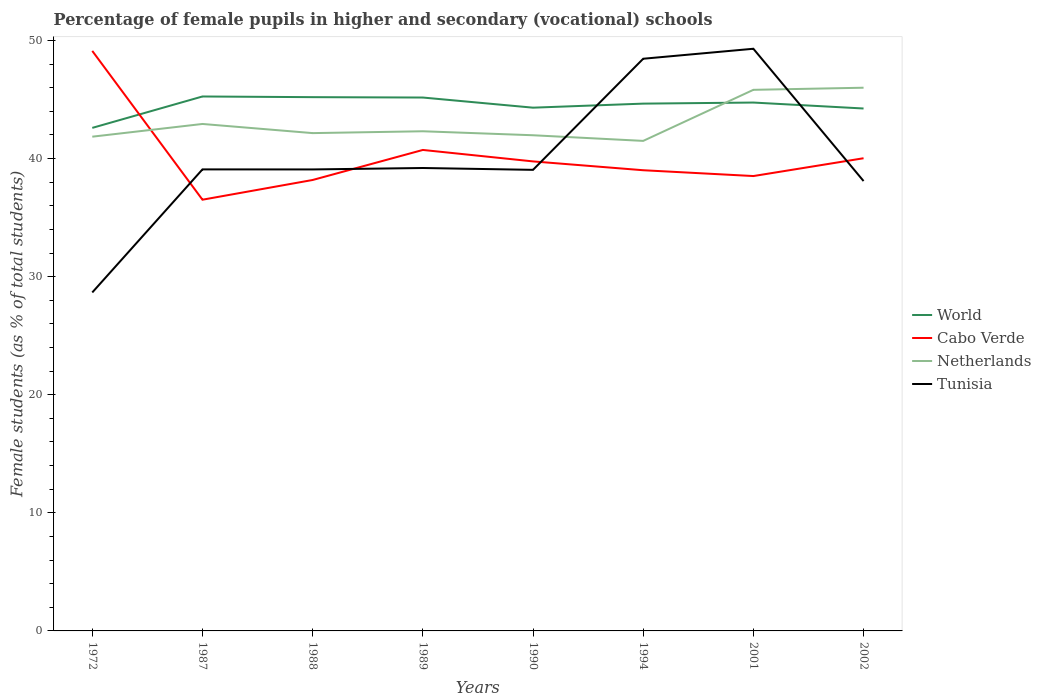Is the number of lines equal to the number of legend labels?
Ensure brevity in your answer.  Yes. Across all years, what is the maximum percentage of female pupils in higher and secondary schools in World?
Provide a succinct answer. 42.6. What is the total percentage of female pupils in higher and secondary schools in Tunisia in the graph?
Give a very brief answer. -19.79. What is the difference between the highest and the second highest percentage of female pupils in higher and secondary schools in Cabo Verde?
Ensure brevity in your answer.  12.6. Is the percentage of female pupils in higher and secondary schools in Cabo Verde strictly greater than the percentage of female pupils in higher and secondary schools in Tunisia over the years?
Offer a very short reply. No. How many lines are there?
Give a very brief answer. 4. How many years are there in the graph?
Your response must be concise. 8. How are the legend labels stacked?
Offer a terse response. Vertical. What is the title of the graph?
Ensure brevity in your answer.  Percentage of female pupils in higher and secondary (vocational) schools. Does "St. Martin (French part)" appear as one of the legend labels in the graph?
Ensure brevity in your answer.  No. What is the label or title of the X-axis?
Ensure brevity in your answer.  Years. What is the label or title of the Y-axis?
Give a very brief answer. Female students (as % of total students). What is the Female students (as % of total students) in World in 1972?
Provide a succinct answer. 42.6. What is the Female students (as % of total students) in Cabo Verde in 1972?
Your answer should be very brief. 49.12. What is the Female students (as % of total students) in Netherlands in 1972?
Offer a terse response. 41.85. What is the Female students (as % of total students) in Tunisia in 1972?
Offer a terse response. 28.66. What is the Female students (as % of total students) of World in 1987?
Your answer should be compact. 45.26. What is the Female students (as % of total students) of Cabo Verde in 1987?
Make the answer very short. 36.52. What is the Female students (as % of total students) in Netherlands in 1987?
Provide a short and direct response. 42.93. What is the Female students (as % of total students) of Tunisia in 1987?
Keep it short and to the point. 39.08. What is the Female students (as % of total students) in World in 1988?
Offer a very short reply. 45.2. What is the Female students (as % of total students) of Cabo Verde in 1988?
Offer a terse response. 38.19. What is the Female students (as % of total students) of Netherlands in 1988?
Provide a short and direct response. 42.16. What is the Female students (as % of total students) of Tunisia in 1988?
Ensure brevity in your answer.  39.08. What is the Female students (as % of total students) in World in 1989?
Your answer should be compact. 45.17. What is the Female students (as % of total students) in Cabo Verde in 1989?
Your answer should be compact. 40.73. What is the Female students (as % of total students) of Netherlands in 1989?
Ensure brevity in your answer.  42.31. What is the Female students (as % of total students) in Tunisia in 1989?
Your answer should be compact. 39.2. What is the Female students (as % of total students) in World in 1990?
Keep it short and to the point. 44.31. What is the Female students (as % of total students) of Cabo Verde in 1990?
Your answer should be very brief. 39.76. What is the Female students (as % of total students) in Netherlands in 1990?
Your answer should be compact. 41.98. What is the Female students (as % of total students) in Tunisia in 1990?
Make the answer very short. 39.05. What is the Female students (as % of total students) in World in 1994?
Ensure brevity in your answer.  44.65. What is the Female students (as % of total students) of Cabo Verde in 1994?
Your answer should be very brief. 39.01. What is the Female students (as % of total students) of Netherlands in 1994?
Your answer should be very brief. 41.5. What is the Female students (as % of total students) of Tunisia in 1994?
Keep it short and to the point. 48.45. What is the Female students (as % of total students) in World in 2001?
Offer a terse response. 44.74. What is the Female students (as % of total students) in Cabo Verde in 2001?
Ensure brevity in your answer.  38.52. What is the Female students (as % of total students) in Netherlands in 2001?
Give a very brief answer. 45.82. What is the Female students (as % of total students) in Tunisia in 2001?
Your answer should be compact. 49.3. What is the Female students (as % of total students) in World in 2002?
Offer a terse response. 44.24. What is the Female students (as % of total students) of Cabo Verde in 2002?
Keep it short and to the point. 40.03. What is the Female students (as % of total students) in Netherlands in 2002?
Your answer should be very brief. 46. What is the Female students (as % of total students) in Tunisia in 2002?
Make the answer very short. 38.1. Across all years, what is the maximum Female students (as % of total students) of World?
Your response must be concise. 45.26. Across all years, what is the maximum Female students (as % of total students) of Cabo Verde?
Make the answer very short. 49.12. Across all years, what is the maximum Female students (as % of total students) in Netherlands?
Make the answer very short. 46. Across all years, what is the maximum Female students (as % of total students) in Tunisia?
Provide a short and direct response. 49.3. Across all years, what is the minimum Female students (as % of total students) of World?
Give a very brief answer. 42.6. Across all years, what is the minimum Female students (as % of total students) in Cabo Verde?
Offer a terse response. 36.52. Across all years, what is the minimum Female students (as % of total students) in Netherlands?
Ensure brevity in your answer.  41.5. Across all years, what is the minimum Female students (as % of total students) in Tunisia?
Your answer should be very brief. 28.66. What is the total Female students (as % of total students) of World in the graph?
Provide a short and direct response. 356.18. What is the total Female students (as % of total students) in Cabo Verde in the graph?
Give a very brief answer. 321.87. What is the total Female students (as % of total students) in Netherlands in the graph?
Ensure brevity in your answer.  344.55. What is the total Female students (as % of total students) in Tunisia in the graph?
Ensure brevity in your answer.  320.92. What is the difference between the Female students (as % of total students) in World in 1972 and that in 1987?
Make the answer very short. -2.66. What is the difference between the Female students (as % of total students) of Cabo Verde in 1972 and that in 1987?
Give a very brief answer. 12.6. What is the difference between the Female students (as % of total students) of Netherlands in 1972 and that in 1987?
Offer a terse response. -1.08. What is the difference between the Female students (as % of total students) in Tunisia in 1972 and that in 1987?
Offer a very short reply. -10.42. What is the difference between the Female students (as % of total students) in World in 1972 and that in 1988?
Provide a succinct answer. -2.6. What is the difference between the Female students (as % of total students) of Cabo Verde in 1972 and that in 1988?
Provide a succinct answer. 10.93. What is the difference between the Female students (as % of total students) of Netherlands in 1972 and that in 1988?
Provide a succinct answer. -0.3. What is the difference between the Female students (as % of total students) of Tunisia in 1972 and that in 1988?
Ensure brevity in your answer.  -10.42. What is the difference between the Female students (as % of total students) in World in 1972 and that in 1989?
Provide a short and direct response. -2.57. What is the difference between the Female students (as % of total students) in Cabo Verde in 1972 and that in 1989?
Make the answer very short. 8.39. What is the difference between the Female students (as % of total students) of Netherlands in 1972 and that in 1989?
Provide a succinct answer. -0.46. What is the difference between the Female students (as % of total students) of Tunisia in 1972 and that in 1989?
Offer a very short reply. -10.54. What is the difference between the Female students (as % of total students) of World in 1972 and that in 1990?
Your answer should be very brief. -1.71. What is the difference between the Female students (as % of total students) of Cabo Verde in 1972 and that in 1990?
Ensure brevity in your answer.  9.36. What is the difference between the Female students (as % of total students) in Netherlands in 1972 and that in 1990?
Keep it short and to the point. -0.12. What is the difference between the Female students (as % of total students) in Tunisia in 1972 and that in 1990?
Keep it short and to the point. -10.38. What is the difference between the Female students (as % of total students) in World in 1972 and that in 1994?
Provide a short and direct response. -2.05. What is the difference between the Female students (as % of total students) in Cabo Verde in 1972 and that in 1994?
Provide a succinct answer. 10.1. What is the difference between the Female students (as % of total students) in Netherlands in 1972 and that in 1994?
Give a very brief answer. 0.36. What is the difference between the Female students (as % of total students) in Tunisia in 1972 and that in 1994?
Your answer should be very brief. -19.79. What is the difference between the Female students (as % of total students) of World in 1972 and that in 2001?
Ensure brevity in your answer.  -2.15. What is the difference between the Female students (as % of total students) of Cabo Verde in 1972 and that in 2001?
Your answer should be very brief. 10.6. What is the difference between the Female students (as % of total students) in Netherlands in 1972 and that in 2001?
Provide a short and direct response. -3.97. What is the difference between the Female students (as % of total students) in Tunisia in 1972 and that in 2001?
Offer a very short reply. -20.64. What is the difference between the Female students (as % of total students) of World in 1972 and that in 2002?
Provide a short and direct response. -1.64. What is the difference between the Female students (as % of total students) of Cabo Verde in 1972 and that in 2002?
Offer a terse response. 9.09. What is the difference between the Female students (as % of total students) in Netherlands in 1972 and that in 2002?
Your answer should be compact. -4.15. What is the difference between the Female students (as % of total students) of Tunisia in 1972 and that in 2002?
Your answer should be compact. -9.43. What is the difference between the Female students (as % of total students) in World in 1987 and that in 1988?
Ensure brevity in your answer.  0.06. What is the difference between the Female students (as % of total students) in Cabo Verde in 1987 and that in 1988?
Provide a short and direct response. -1.67. What is the difference between the Female students (as % of total students) in Netherlands in 1987 and that in 1988?
Your answer should be very brief. 0.77. What is the difference between the Female students (as % of total students) of Tunisia in 1987 and that in 1988?
Offer a very short reply. 0.01. What is the difference between the Female students (as % of total students) in World in 1987 and that in 1989?
Provide a succinct answer. 0.09. What is the difference between the Female students (as % of total students) in Cabo Verde in 1987 and that in 1989?
Make the answer very short. -4.21. What is the difference between the Female students (as % of total students) of Netherlands in 1987 and that in 1989?
Give a very brief answer. 0.62. What is the difference between the Female students (as % of total students) of Tunisia in 1987 and that in 1989?
Offer a very short reply. -0.12. What is the difference between the Female students (as % of total students) in World in 1987 and that in 1990?
Give a very brief answer. 0.95. What is the difference between the Female students (as % of total students) of Cabo Verde in 1987 and that in 1990?
Offer a terse response. -3.24. What is the difference between the Female students (as % of total students) of Netherlands in 1987 and that in 1990?
Give a very brief answer. 0.96. What is the difference between the Female students (as % of total students) of Tunisia in 1987 and that in 1990?
Your answer should be very brief. 0.04. What is the difference between the Female students (as % of total students) in World in 1987 and that in 1994?
Your answer should be compact. 0.61. What is the difference between the Female students (as % of total students) in Cabo Verde in 1987 and that in 1994?
Ensure brevity in your answer.  -2.5. What is the difference between the Female students (as % of total students) in Netherlands in 1987 and that in 1994?
Provide a succinct answer. 1.43. What is the difference between the Female students (as % of total students) in Tunisia in 1987 and that in 1994?
Your answer should be compact. -9.37. What is the difference between the Female students (as % of total students) in World in 1987 and that in 2001?
Offer a terse response. 0.51. What is the difference between the Female students (as % of total students) in Cabo Verde in 1987 and that in 2001?
Ensure brevity in your answer.  -2. What is the difference between the Female students (as % of total students) of Netherlands in 1987 and that in 2001?
Your answer should be compact. -2.89. What is the difference between the Female students (as % of total students) of Tunisia in 1987 and that in 2001?
Provide a succinct answer. -10.21. What is the difference between the Female students (as % of total students) in Cabo Verde in 1987 and that in 2002?
Keep it short and to the point. -3.51. What is the difference between the Female students (as % of total students) in Netherlands in 1987 and that in 2002?
Keep it short and to the point. -3.07. What is the difference between the Female students (as % of total students) in Tunisia in 1987 and that in 2002?
Make the answer very short. 0.99. What is the difference between the Female students (as % of total students) in World in 1988 and that in 1989?
Provide a short and direct response. 0.03. What is the difference between the Female students (as % of total students) in Cabo Verde in 1988 and that in 1989?
Make the answer very short. -2.54. What is the difference between the Female students (as % of total students) of Netherlands in 1988 and that in 1989?
Offer a terse response. -0.16. What is the difference between the Female students (as % of total students) in Tunisia in 1988 and that in 1989?
Make the answer very short. -0.12. What is the difference between the Female students (as % of total students) in World in 1988 and that in 1990?
Make the answer very short. 0.89. What is the difference between the Female students (as % of total students) in Cabo Verde in 1988 and that in 1990?
Offer a very short reply. -1.57. What is the difference between the Female students (as % of total students) in Netherlands in 1988 and that in 1990?
Offer a very short reply. 0.18. What is the difference between the Female students (as % of total students) of Tunisia in 1988 and that in 1990?
Make the answer very short. 0.03. What is the difference between the Female students (as % of total students) in World in 1988 and that in 1994?
Offer a terse response. 0.55. What is the difference between the Female students (as % of total students) in Cabo Verde in 1988 and that in 1994?
Offer a very short reply. -0.83. What is the difference between the Female students (as % of total students) in Netherlands in 1988 and that in 1994?
Offer a terse response. 0.66. What is the difference between the Female students (as % of total students) in Tunisia in 1988 and that in 1994?
Provide a short and direct response. -9.37. What is the difference between the Female students (as % of total students) in World in 1988 and that in 2001?
Provide a succinct answer. 0.46. What is the difference between the Female students (as % of total students) of Cabo Verde in 1988 and that in 2001?
Your answer should be very brief. -0.33. What is the difference between the Female students (as % of total students) in Netherlands in 1988 and that in 2001?
Offer a terse response. -3.66. What is the difference between the Female students (as % of total students) of Tunisia in 1988 and that in 2001?
Give a very brief answer. -10.22. What is the difference between the Female students (as % of total students) in World in 1988 and that in 2002?
Keep it short and to the point. 0.96. What is the difference between the Female students (as % of total students) of Cabo Verde in 1988 and that in 2002?
Offer a terse response. -1.84. What is the difference between the Female students (as % of total students) in Netherlands in 1988 and that in 2002?
Offer a terse response. -3.84. What is the difference between the Female students (as % of total students) in Tunisia in 1988 and that in 2002?
Offer a very short reply. 0.98. What is the difference between the Female students (as % of total students) of World in 1989 and that in 1990?
Your response must be concise. 0.86. What is the difference between the Female students (as % of total students) in Cabo Verde in 1989 and that in 1990?
Offer a terse response. 0.97. What is the difference between the Female students (as % of total students) in Netherlands in 1989 and that in 1990?
Provide a succinct answer. 0.34. What is the difference between the Female students (as % of total students) of Tunisia in 1989 and that in 1990?
Offer a terse response. 0.16. What is the difference between the Female students (as % of total students) of World in 1989 and that in 1994?
Ensure brevity in your answer.  0.52. What is the difference between the Female students (as % of total students) in Cabo Verde in 1989 and that in 1994?
Your answer should be compact. 1.72. What is the difference between the Female students (as % of total students) of Netherlands in 1989 and that in 1994?
Provide a short and direct response. 0.81. What is the difference between the Female students (as % of total students) in Tunisia in 1989 and that in 1994?
Offer a terse response. -9.25. What is the difference between the Female students (as % of total students) in World in 1989 and that in 2001?
Offer a very short reply. 0.42. What is the difference between the Female students (as % of total students) in Cabo Verde in 1989 and that in 2001?
Provide a short and direct response. 2.21. What is the difference between the Female students (as % of total students) in Netherlands in 1989 and that in 2001?
Give a very brief answer. -3.51. What is the difference between the Female students (as % of total students) of Tunisia in 1989 and that in 2001?
Your answer should be compact. -10.1. What is the difference between the Female students (as % of total students) in World in 1989 and that in 2002?
Provide a succinct answer. 0.93. What is the difference between the Female students (as % of total students) in Cabo Verde in 1989 and that in 2002?
Offer a terse response. 0.7. What is the difference between the Female students (as % of total students) of Netherlands in 1989 and that in 2002?
Give a very brief answer. -3.69. What is the difference between the Female students (as % of total students) of Tunisia in 1989 and that in 2002?
Provide a short and direct response. 1.1. What is the difference between the Female students (as % of total students) of World in 1990 and that in 1994?
Your response must be concise. -0.34. What is the difference between the Female students (as % of total students) in Cabo Verde in 1990 and that in 1994?
Make the answer very short. 0.75. What is the difference between the Female students (as % of total students) of Netherlands in 1990 and that in 1994?
Make the answer very short. 0.48. What is the difference between the Female students (as % of total students) of Tunisia in 1990 and that in 1994?
Ensure brevity in your answer.  -9.41. What is the difference between the Female students (as % of total students) in World in 1990 and that in 2001?
Keep it short and to the point. -0.43. What is the difference between the Female students (as % of total students) in Cabo Verde in 1990 and that in 2001?
Give a very brief answer. 1.24. What is the difference between the Female students (as % of total students) of Netherlands in 1990 and that in 2001?
Provide a succinct answer. -3.85. What is the difference between the Female students (as % of total students) of Tunisia in 1990 and that in 2001?
Provide a succinct answer. -10.25. What is the difference between the Female students (as % of total students) of World in 1990 and that in 2002?
Your response must be concise. 0.07. What is the difference between the Female students (as % of total students) of Cabo Verde in 1990 and that in 2002?
Keep it short and to the point. -0.27. What is the difference between the Female students (as % of total students) of Netherlands in 1990 and that in 2002?
Your response must be concise. -4.02. What is the difference between the Female students (as % of total students) of Tunisia in 1990 and that in 2002?
Offer a terse response. 0.95. What is the difference between the Female students (as % of total students) of World in 1994 and that in 2001?
Keep it short and to the point. -0.09. What is the difference between the Female students (as % of total students) of Cabo Verde in 1994 and that in 2001?
Your response must be concise. 0.49. What is the difference between the Female students (as % of total students) in Netherlands in 1994 and that in 2001?
Offer a very short reply. -4.32. What is the difference between the Female students (as % of total students) of Tunisia in 1994 and that in 2001?
Offer a very short reply. -0.85. What is the difference between the Female students (as % of total students) in World in 1994 and that in 2002?
Offer a very short reply. 0.41. What is the difference between the Female students (as % of total students) in Cabo Verde in 1994 and that in 2002?
Make the answer very short. -1.02. What is the difference between the Female students (as % of total students) of Netherlands in 1994 and that in 2002?
Keep it short and to the point. -4.5. What is the difference between the Female students (as % of total students) in Tunisia in 1994 and that in 2002?
Offer a terse response. 10.36. What is the difference between the Female students (as % of total students) in World in 2001 and that in 2002?
Keep it short and to the point. 0.5. What is the difference between the Female students (as % of total students) of Cabo Verde in 2001 and that in 2002?
Offer a very short reply. -1.51. What is the difference between the Female students (as % of total students) of Netherlands in 2001 and that in 2002?
Your answer should be compact. -0.18. What is the difference between the Female students (as % of total students) in Tunisia in 2001 and that in 2002?
Your answer should be compact. 11.2. What is the difference between the Female students (as % of total students) of World in 1972 and the Female students (as % of total students) of Cabo Verde in 1987?
Keep it short and to the point. 6.08. What is the difference between the Female students (as % of total students) in World in 1972 and the Female students (as % of total students) in Netherlands in 1987?
Keep it short and to the point. -0.33. What is the difference between the Female students (as % of total students) of World in 1972 and the Female students (as % of total students) of Tunisia in 1987?
Give a very brief answer. 3.51. What is the difference between the Female students (as % of total students) of Cabo Verde in 1972 and the Female students (as % of total students) of Netherlands in 1987?
Provide a short and direct response. 6.19. What is the difference between the Female students (as % of total students) of Cabo Verde in 1972 and the Female students (as % of total students) of Tunisia in 1987?
Offer a terse response. 10.03. What is the difference between the Female students (as % of total students) in Netherlands in 1972 and the Female students (as % of total students) in Tunisia in 1987?
Ensure brevity in your answer.  2.77. What is the difference between the Female students (as % of total students) in World in 1972 and the Female students (as % of total students) in Cabo Verde in 1988?
Offer a terse response. 4.41. What is the difference between the Female students (as % of total students) in World in 1972 and the Female students (as % of total students) in Netherlands in 1988?
Keep it short and to the point. 0.44. What is the difference between the Female students (as % of total students) of World in 1972 and the Female students (as % of total students) of Tunisia in 1988?
Offer a terse response. 3.52. What is the difference between the Female students (as % of total students) in Cabo Verde in 1972 and the Female students (as % of total students) in Netherlands in 1988?
Offer a terse response. 6.96. What is the difference between the Female students (as % of total students) of Cabo Verde in 1972 and the Female students (as % of total students) of Tunisia in 1988?
Keep it short and to the point. 10.04. What is the difference between the Female students (as % of total students) of Netherlands in 1972 and the Female students (as % of total students) of Tunisia in 1988?
Offer a terse response. 2.78. What is the difference between the Female students (as % of total students) of World in 1972 and the Female students (as % of total students) of Cabo Verde in 1989?
Offer a terse response. 1.87. What is the difference between the Female students (as % of total students) of World in 1972 and the Female students (as % of total students) of Netherlands in 1989?
Ensure brevity in your answer.  0.29. What is the difference between the Female students (as % of total students) of World in 1972 and the Female students (as % of total students) of Tunisia in 1989?
Offer a very short reply. 3.4. What is the difference between the Female students (as % of total students) in Cabo Verde in 1972 and the Female students (as % of total students) in Netherlands in 1989?
Ensure brevity in your answer.  6.8. What is the difference between the Female students (as % of total students) of Cabo Verde in 1972 and the Female students (as % of total students) of Tunisia in 1989?
Provide a short and direct response. 9.92. What is the difference between the Female students (as % of total students) in Netherlands in 1972 and the Female students (as % of total students) in Tunisia in 1989?
Offer a terse response. 2.65. What is the difference between the Female students (as % of total students) of World in 1972 and the Female students (as % of total students) of Cabo Verde in 1990?
Provide a succinct answer. 2.84. What is the difference between the Female students (as % of total students) of World in 1972 and the Female students (as % of total students) of Netherlands in 1990?
Keep it short and to the point. 0.62. What is the difference between the Female students (as % of total students) in World in 1972 and the Female students (as % of total students) in Tunisia in 1990?
Make the answer very short. 3.55. What is the difference between the Female students (as % of total students) in Cabo Verde in 1972 and the Female students (as % of total students) in Netherlands in 1990?
Keep it short and to the point. 7.14. What is the difference between the Female students (as % of total students) in Cabo Verde in 1972 and the Female students (as % of total students) in Tunisia in 1990?
Ensure brevity in your answer.  10.07. What is the difference between the Female students (as % of total students) in Netherlands in 1972 and the Female students (as % of total students) in Tunisia in 1990?
Offer a terse response. 2.81. What is the difference between the Female students (as % of total students) in World in 1972 and the Female students (as % of total students) in Cabo Verde in 1994?
Give a very brief answer. 3.59. What is the difference between the Female students (as % of total students) in World in 1972 and the Female students (as % of total students) in Netherlands in 1994?
Make the answer very short. 1.1. What is the difference between the Female students (as % of total students) in World in 1972 and the Female students (as % of total students) in Tunisia in 1994?
Ensure brevity in your answer.  -5.86. What is the difference between the Female students (as % of total students) of Cabo Verde in 1972 and the Female students (as % of total students) of Netherlands in 1994?
Provide a short and direct response. 7.62. What is the difference between the Female students (as % of total students) of Cabo Verde in 1972 and the Female students (as % of total students) of Tunisia in 1994?
Give a very brief answer. 0.66. What is the difference between the Female students (as % of total students) in Netherlands in 1972 and the Female students (as % of total students) in Tunisia in 1994?
Keep it short and to the point. -6.6. What is the difference between the Female students (as % of total students) in World in 1972 and the Female students (as % of total students) in Cabo Verde in 2001?
Offer a terse response. 4.08. What is the difference between the Female students (as % of total students) of World in 1972 and the Female students (as % of total students) of Netherlands in 2001?
Your response must be concise. -3.22. What is the difference between the Female students (as % of total students) in World in 1972 and the Female students (as % of total students) in Tunisia in 2001?
Give a very brief answer. -6.7. What is the difference between the Female students (as % of total students) in Cabo Verde in 1972 and the Female students (as % of total students) in Netherlands in 2001?
Provide a succinct answer. 3.3. What is the difference between the Female students (as % of total students) in Cabo Verde in 1972 and the Female students (as % of total students) in Tunisia in 2001?
Provide a succinct answer. -0.18. What is the difference between the Female students (as % of total students) in Netherlands in 1972 and the Female students (as % of total students) in Tunisia in 2001?
Keep it short and to the point. -7.44. What is the difference between the Female students (as % of total students) in World in 1972 and the Female students (as % of total students) in Cabo Verde in 2002?
Your response must be concise. 2.57. What is the difference between the Female students (as % of total students) of World in 1972 and the Female students (as % of total students) of Netherlands in 2002?
Keep it short and to the point. -3.4. What is the difference between the Female students (as % of total students) of World in 1972 and the Female students (as % of total students) of Tunisia in 2002?
Give a very brief answer. 4.5. What is the difference between the Female students (as % of total students) of Cabo Verde in 1972 and the Female students (as % of total students) of Netherlands in 2002?
Offer a terse response. 3.12. What is the difference between the Female students (as % of total students) of Cabo Verde in 1972 and the Female students (as % of total students) of Tunisia in 2002?
Your answer should be very brief. 11.02. What is the difference between the Female students (as % of total students) in Netherlands in 1972 and the Female students (as % of total students) in Tunisia in 2002?
Provide a succinct answer. 3.76. What is the difference between the Female students (as % of total students) of World in 1987 and the Female students (as % of total students) of Cabo Verde in 1988?
Ensure brevity in your answer.  7.07. What is the difference between the Female students (as % of total students) of World in 1987 and the Female students (as % of total students) of Netherlands in 1988?
Your answer should be very brief. 3.1. What is the difference between the Female students (as % of total students) in World in 1987 and the Female students (as % of total students) in Tunisia in 1988?
Provide a short and direct response. 6.18. What is the difference between the Female students (as % of total students) of Cabo Verde in 1987 and the Female students (as % of total students) of Netherlands in 1988?
Your answer should be very brief. -5.64. What is the difference between the Female students (as % of total students) of Cabo Verde in 1987 and the Female students (as % of total students) of Tunisia in 1988?
Ensure brevity in your answer.  -2.56. What is the difference between the Female students (as % of total students) in Netherlands in 1987 and the Female students (as % of total students) in Tunisia in 1988?
Give a very brief answer. 3.85. What is the difference between the Female students (as % of total students) in World in 1987 and the Female students (as % of total students) in Cabo Verde in 1989?
Provide a succinct answer. 4.53. What is the difference between the Female students (as % of total students) of World in 1987 and the Female students (as % of total students) of Netherlands in 1989?
Make the answer very short. 2.95. What is the difference between the Female students (as % of total students) of World in 1987 and the Female students (as % of total students) of Tunisia in 1989?
Offer a terse response. 6.06. What is the difference between the Female students (as % of total students) of Cabo Verde in 1987 and the Female students (as % of total students) of Netherlands in 1989?
Your answer should be very brief. -5.79. What is the difference between the Female students (as % of total students) of Cabo Verde in 1987 and the Female students (as % of total students) of Tunisia in 1989?
Keep it short and to the point. -2.68. What is the difference between the Female students (as % of total students) in Netherlands in 1987 and the Female students (as % of total students) in Tunisia in 1989?
Your response must be concise. 3.73. What is the difference between the Female students (as % of total students) in World in 1987 and the Female students (as % of total students) in Cabo Verde in 1990?
Provide a succinct answer. 5.5. What is the difference between the Female students (as % of total students) in World in 1987 and the Female students (as % of total students) in Netherlands in 1990?
Offer a terse response. 3.28. What is the difference between the Female students (as % of total students) in World in 1987 and the Female students (as % of total students) in Tunisia in 1990?
Provide a succinct answer. 6.21. What is the difference between the Female students (as % of total students) in Cabo Verde in 1987 and the Female students (as % of total students) in Netherlands in 1990?
Make the answer very short. -5.46. What is the difference between the Female students (as % of total students) in Cabo Verde in 1987 and the Female students (as % of total students) in Tunisia in 1990?
Offer a terse response. -2.53. What is the difference between the Female students (as % of total students) of Netherlands in 1987 and the Female students (as % of total students) of Tunisia in 1990?
Provide a short and direct response. 3.89. What is the difference between the Female students (as % of total students) of World in 1987 and the Female students (as % of total students) of Cabo Verde in 1994?
Your response must be concise. 6.25. What is the difference between the Female students (as % of total students) in World in 1987 and the Female students (as % of total students) in Netherlands in 1994?
Offer a terse response. 3.76. What is the difference between the Female students (as % of total students) in World in 1987 and the Female students (as % of total students) in Tunisia in 1994?
Keep it short and to the point. -3.2. What is the difference between the Female students (as % of total students) of Cabo Verde in 1987 and the Female students (as % of total students) of Netherlands in 1994?
Ensure brevity in your answer.  -4.98. What is the difference between the Female students (as % of total students) of Cabo Verde in 1987 and the Female students (as % of total students) of Tunisia in 1994?
Provide a short and direct response. -11.94. What is the difference between the Female students (as % of total students) in Netherlands in 1987 and the Female students (as % of total students) in Tunisia in 1994?
Your answer should be compact. -5.52. What is the difference between the Female students (as % of total students) in World in 1987 and the Female students (as % of total students) in Cabo Verde in 2001?
Your response must be concise. 6.74. What is the difference between the Female students (as % of total students) in World in 1987 and the Female students (as % of total students) in Netherlands in 2001?
Your answer should be very brief. -0.56. What is the difference between the Female students (as % of total students) of World in 1987 and the Female students (as % of total students) of Tunisia in 2001?
Make the answer very short. -4.04. What is the difference between the Female students (as % of total students) in Cabo Verde in 1987 and the Female students (as % of total students) in Netherlands in 2001?
Keep it short and to the point. -9.3. What is the difference between the Female students (as % of total students) of Cabo Verde in 1987 and the Female students (as % of total students) of Tunisia in 2001?
Keep it short and to the point. -12.78. What is the difference between the Female students (as % of total students) in Netherlands in 1987 and the Female students (as % of total students) in Tunisia in 2001?
Offer a terse response. -6.37. What is the difference between the Female students (as % of total students) in World in 1987 and the Female students (as % of total students) in Cabo Verde in 2002?
Provide a succinct answer. 5.23. What is the difference between the Female students (as % of total students) in World in 1987 and the Female students (as % of total students) in Netherlands in 2002?
Make the answer very short. -0.74. What is the difference between the Female students (as % of total students) in World in 1987 and the Female students (as % of total students) in Tunisia in 2002?
Make the answer very short. 7.16. What is the difference between the Female students (as % of total students) of Cabo Verde in 1987 and the Female students (as % of total students) of Netherlands in 2002?
Offer a terse response. -9.48. What is the difference between the Female students (as % of total students) in Cabo Verde in 1987 and the Female students (as % of total students) in Tunisia in 2002?
Make the answer very short. -1.58. What is the difference between the Female students (as % of total students) of Netherlands in 1987 and the Female students (as % of total students) of Tunisia in 2002?
Ensure brevity in your answer.  4.83. What is the difference between the Female students (as % of total students) of World in 1988 and the Female students (as % of total students) of Cabo Verde in 1989?
Offer a terse response. 4.47. What is the difference between the Female students (as % of total students) in World in 1988 and the Female students (as % of total students) in Netherlands in 1989?
Your answer should be very brief. 2.89. What is the difference between the Female students (as % of total students) of World in 1988 and the Female students (as % of total students) of Tunisia in 1989?
Your answer should be compact. 6. What is the difference between the Female students (as % of total students) in Cabo Verde in 1988 and the Female students (as % of total students) in Netherlands in 1989?
Give a very brief answer. -4.13. What is the difference between the Female students (as % of total students) in Cabo Verde in 1988 and the Female students (as % of total students) in Tunisia in 1989?
Your answer should be very brief. -1.01. What is the difference between the Female students (as % of total students) of Netherlands in 1988 and the Female students (as % of total students) of Tunisia in 1989?
Provide a succinct answer. 2.96. What is the difference between the Female students (as % of total students) of World in 1988 and the Female students (as % of total students) of Cabo Verde in 1990?
Provide a succinct answer. 5.44. What is the difference between the Female students (as % of total students) of World in 1988 and the Female students (as % of total students) of Netherlands in 1990?
Provide a short and direct response. 3.23. What is the difference between the Female students (as % of total students) in World in 1988 and the Female students (as % of total students) in Tunisia in 1990?
Your answer should be very brief. 6.16. What is the difference between the Female students (as % of total students) of Cabo Verde in 1988 and the Female students (as % of total students) of Netherlands in 1990?
Offer a terse response. -3.79. What is the difference between the Female students (as % of total students) of Cabo Verde in 1988 and the Female students (as % of total students) of Tunisia in 1990?
Offer a very short reply. -0.86. What is the difference between the Female students (as % of total students) in Netherlands in 1988 and the Female students (as % of total students) in Tunisia in 1990?
Your answer should be compact. 3.11. What is the difference between the Female students (as % of total students) of World in 1988 and the Female students (as % of total students) of Cabo Verde in 1994?
Offer a terse response. 6.19. What is the difference between the Female students (as % of total students) of World in 1988 and the Female students (as % of total students) of Netherlands in 1994?
Your response must be concise. 3.7. What is the difference between the Female students (as % of total students) in World in 1988 and the Female students (as % of total students) in Tunisia in 1994?
Ensure brevity in your answer.  -3.25. What is the difference between the Female students (as % of total students) in Cabo Verde in 1988 and the Female students (as % of total students) in Netherlands in 1994?
Ensure brevity in your answer.  -3.31. What is the difference between the Female students (as % of total students) of Cabo Verde in 1988 and the Female students (as % of total students) of Tunisia in 1994?
Your response must be concise. -10.27. What is the difference between the Female students (as % of total students) of Netherlands in 1988 and the Female students (as % of total students) of Tunisia in 1994?
Offer a terse response. -6.3. What is the difference between the Female students (as % of total students) in World in 1988 and the Female students (as % of total students) in Cabo Verde in 2001?
Keep it short and to the point. 6.68. What is the difference between the Female students (as % of total students) in World in 1988 and the Female students (as % of total students) in Netherlands in 2001?
Keep it short and to the point. -0.62. What is the difference between the Female students (as % of total students) of World in 1988 and the Female students (as % of total students) of Tunisia in 2001?
Keep it short and to the point. -4.1. What is the difference between the Female students (as % of total students) in Cabo Verde in 1988 and the Female students (as % of total students) in Netherlands in 2001?
Offer a terse response. -7.63. What is the difference between the Female students (as % of total students) of Cabo Verde in 1988 and the Female students (as % of total students) of Tunisia in 2001?
Provide a succinct answer. -11.11. What is the difference between the Female students (as % of total students) of Netherlands in 1988 and the Female students (as % of total students) of Tunisia in 2001?
Make the answer very short. -7.14. What is the difference between the Female students (as % of total students) of World in 1988 and the Female students (as % of total students) of Cabo Verde in 2002?
Keep it short and to the point. 5.17. What is the difference between the Female students (as % of total students) in World in 1988 and the Female students (as % of total students) in Netherlands in 2002?
Make the answer very short. -0.8. What is the difference between the Female students (as % of total students) of World in 1988 and the Female students (as % of total students) of Tunisia in 2002?
Keep it short and to the point. 7.1. What is the difference between the Female students (as % of total students) of Cabo Verde in 1988 and the Female students (as % of total students) of Netherlands in 2002?
Your response must be concise. -7.81. What is the difference between the Female students (as % of total students) of Cabo Verde in 1988 and the Female students (as % of total students) of Tunisia in 2002?
Make the answer very short. 0.09. What is the difference between the Female students (as % of total students) in Netherlands in 1988 and the Female students (as % of total students) in Tunisia in 2002?
Your response must be concise. 4.06. What is the difference between the Female students (as % of total students) in World in 1989 and the Female students (as % of total students) in Cabo Verde in 1990?
Your response must be concise. 5.41. What is the difference between the Female students (as % of total students) of World in 1989 and the Female students (as % of total students) of Netherlands in 1990?
Make the answer very short. 3.19. What is the difference between the Female students (as % of total students) in World in 1989 and the Female students (as % of total students) in Tunisia in 1990?
Your answer should be very brief. 6.12. What is the difference between the Female students (as % of total students) of Cabo Verde in 1989 and the Female students (as % of total students) of Netherlands in 1990?
Your response must be concise. -1.25. What is the difference between the Female students (as % of total students) in Cabo Verde in 1989 and the Female students (as % of total students) in Tunisia in 1990?
Provide a succinct answer. 1.69. What is the difference between the Female students (as % of total students) in Netherlands in 1989 and the Female students (as % of total students) in Tunisia in 1990?
Your answer should be very brief. 3.27. What is the difference between the Female students (as % of total students) of World in 1989 and the Female students (as % of total students) of Cabo Verde in 1994?
Keep it short and to the point. 6.16. What is the difference between the Female students (as % of total students) in World in 1989 and the Female students (as % of total students) in Netherlands in 1994?
Give a very brief answer. 3.67. What is the difference between the Female students (as % of total students) of World in 1989 and the Female students (as % of total students) of Tunisia in 1994?
Your response must be concise. -3.28. What is the difference between the Female students (as % of total students) in Cabo Verde in 1989 and the Female students (as % of total students) in Netherlands in 1994?
Provide a short and direct response. -0.77. What is the difference between the Female students (as % of total students) of Cabo Verde in 1989 and the Female students (as % of total students) of Tunisia in 1994?
Your answer should be compact. -7.72. What is the difference between the Female students (as % of total students) of Netherlands in 1989 and the Female students (as % of total students) of Tunisia in 1994?
Offer a terse response. -6.14. What is the difference between the Female students (as % of total students) of World in 1989 and the Female students (as % of total students) of Cabo Verde in 2001?
Offer a terse response. 6.65. What is the difference between the Female students (as % of total students) of World in 1989 and the Female students (as % of total students) of Netherlands in 2001?
Ensure brevity in your answer.  -0.65. What is the difference between the Female students (as % of total students) of World in 1989 and the Female students (as % of total students) of Tunisia in 2001?
Give a very brief answer. -4.13. What is the difference between the Female students (as % of total students) of Cabo Verde in 1989 and the Female students (as % of total students) of Netherlands in 2001?
Your response must be concise. -5.09. What is the difference between the Female students (as % of total students) in Cabo Verde in 1989 and the Female students (as % of total students) in Tunisia in 2001?
Provide a short and direct response. -8.57. What is the difference between the Female students (as % of total students) of Netherlands in 1989 and the Female students (as % of total students) of Tunisia in 2001?
Ensure brevity in your answer.  -6.99. What is the difference between the Female students (as % of total students) in World in 1989 and the Female students (as % of total students) in Cabo Verde in 2002?
Provide a short and direct response. 5.14. What is the difference between the Female students (as % of total students) in World in 1989 and the Female students (as % of total students) in Netherlands in 2002?
Your answer should be compact. -0.83. What is the difference between the Female students (as % of total students) of World in 1989 and the Female students (as % of total students) of Tunisia in 2002?
Your answer should be very brief. 7.07. What is the difference between the Female students (as % of total students) of Cabo Verde in 1989 and the Female students (as % of total students) of Netherlands in 2002?
Make the answer very short. -5.27. What is the difference between the Female students (as % of total students) of Cabo Verde in 1989 and the Female students (as % of total students) of Tunisia in 2002?
Offer a very short reply. 2.63. What is the difference between the Female students (as % of total students) in Netherlands in 1989 and the Female students (as % of total students) in Tunisia in 2002?
Make the answer very short. 4.22. What is the difference between the Female students (as % of total students) of World in 1990 and the Female students (as % of total students) of Cabo Verde in 1994?
Provide a succinct answer. 5.3. What is the difference between the Female students (as % of total students) of World in 1990 and the Female students (as % of total students) of Netherlands in 1994?
Your response must be concise. 2.81. What is the difference between the Female students (as % of total students) in World in 1990 and the Female students (as % of total students) in Tunisia in 1994?
Make the answer very short. -4.14. What is the difference between the Female students (as % of total students) in Cabo Verde in 1990 and the Female students (as % of total students) in Netherlands in 1994?
Your answer should be very brief. -1.74. What is the difference between the Female students (as % of total students) of Cabo Verde in 1990 and the Female students (as % of total students) of Tunisia in 1994?
Offer a very short reply. -8.69. What is the difference between the Female students (as % of total students) of Netherlands in 1990 and the Female students (as % of total students) of Tunisia in 1994?
Provide a short and direct response. -6.48. What is the difference between the Female students (as % of total students) of World in 1990 and the Female students (as % of total students) of Cabo Verde in 2001?
Provide a succinct answer. 5.79. What is the difference between the Female students (as % of total students) of World in 1990 and the Female students (as % of total students) of Netherlands in 2001?
Offer a terse response. -1.51. What is the difference between the Female students (as % of total students) in World in 1990 and the Female students (as % of total students) in Tunisia in 2001?
Your response must be concise. -4.99. What is the difference between the Female students (as % of total students) of Cabo Verde in 1990 and the Female students (as % of total students) of Netherlands in 2001?
Your answer should be very brief. -6.06. What is the difference between the Female students (as % of total students) of Cabo Verde in 1990 and the Female students (as % of total students) of Tunisia in 2001?
Ensure brevity in your answer.  -9.54. What is the difference between the Female students (as % of total students) in Netherlands in 1990 and the Female students (as % of total students) in Tunisia in 2001?
Offer a very short reply. -7.32. What is the difference between the Female students (as % of total students) of World in 1990 and the Female students (as % of total students) of Cabo Verde in 2002?
Provide a succinct answer. 4.28. What is the difference between the Female students (as % of total students) of World in 1990 and the Female students (as % of total students) of Netherlands in 2002?
Offer a very short reply. -1.69. What is the difference between the Female students (as % of total students) of World in 1990 and the Female students (as % of total students) of Tunisia in 2002?
Offer a very short reply. 6.21. What is the difference between the Female students (as % of total students) of Cabo Verde in 1990 and the Female students (as % of total students) of Netherlands in 2002?
Offer a terse response. -6.24. What is the difference between the Female students (as % of total students) of Cabo Verde in 1990 and the Female students (as % of total students) of Tunisia in 2002?
Give a very brief answer. 1.66. What is the difference between the Female students (as % of total students) of Netherlands in 1990 and the Female students (as % of total students) of Tunisia in 2002?
Make the answer very short. 3.88. What is the difference between the Female students (as % of total students) of World in 1994 and the Female students (as % of total students) of Cabo Verde in 2001?
Provide a succinct answer. 6.13. What is the difference between the Female students (as % of total students) in World in 1994 and the Female students (as % of total students) in Netherlands in 2001?
Ensure brevity in your answer.  -1.17. What is the difference between the Female students (as % of total students) in World in 1994 and the Female students (as % of total students) in Tunisia in 2001?
Offer a very short reply. -4.65. What is the difference between the Female students (as % of total students) of Cabo Verde in 1994 and the Female students (as % of total students) of Netherlands in 2001?
Provide a short and direct response. -6.81. What is the difference between the Female students (as % of total students) of Cabo Verde in 1994 and the Female students (as % of total students) of Tunisia in 2001?
Make the answer very short. -10.29. What is the difference between the Female students (as % of total students) of Netherlands in 1994 and the Female students (as % of total students) of Tunisia in 2001?
Your answer should be very brief. -7.8. What is the difference between the Female students (as % of total students) in World in 1994 and the Female students (as % of total students) in Cabo Verde in 2002?
Provide a succinct answer. 4.62. What is the difference between the Female students (as % of total students) of World in 1994 and the Female students (as % of total students) of Netherlands in 2002?
Your answer should be very brief. -1.35. What is the difference between the Female students (as % of total students) in World in 1994 and the Female students (as % of total students) in Tunisia in 2002?
Your answer should be very brief. 6.56. What is the difference between the Female students (as % of total students) of Cabo Verde in 1994 and the Female students (as % of total students) of Netherlands in 2002?
Your answer should be compact. -6.99. What is the difference between the Female students (as % of total students) of Cabo Verde in 1994 and the Female students (as % of total students) of Tunisia in 2002?
Your answer should be compact. 0.92. What is the difference between the Female students (as % of total students) in Netherlands in 1994 and the Female students (as % of total students) in Tunisia in 2002?
Provide a short and direct response. 3.4. What is the difference between the Female students (as % of total students) in World in 2001 and the Female students (as % of total students) in Cabo Verde in 2002?
Offer a very short reply. 4.72. What is the difference between the Female students (as % of total students) in World in 2001 and the Female students (as % of total students) in Netherlands in 2002?
Your answer should be compact. -1.25. What is the difference between the Female students (as % of total students) in World in 2001 and the Female students (as % of total students) in Tunisia in 2002?
Provide a succinct answer. 6.65. What is the difference between the Female students (as % of total students) of Cabo Verde in 2001 and the Female students (as % of total students) of Netherlands in 2002?
Ensure brevity in your answer.  -7.48. What is the difference between the Female students (as % of total students) in Cabo Verde in 2001 and the Female students (as % of total students) in Tunisia in 2002?
Give a very brief answer. 0.42. What is the difference between the Female students (as % of total students) of Netherlands in 2001 and the Female students (as % of total students) of Tunisia in 2002?
Ensure brevity in your answer.  7.72. What is the average Female students (as % of total students) in World per year?
Your response must be concise. 44.52. What is the average Female students (as % of total students) of Cabo Verde per year?
Your response must be concise. 40.23. What is the average Female students (as % of total students) in Netherlands per year?
Your response must be concise. 43.07. What is the average Female students (as % of total students) of Tunisia per year?
Provide a short and direct response. 40.12. In the year 1972, what is the difference between the Female students (as % of total students) in World and Female students (as % of total students) in Cabo Verde?
Ensure brevity in your answer.  -6.52. In the year 1972, what is the difference between the Female students (as % of total students) of World and Female students (as % of total students) of Netherlands?
Ensure brevity in your answer.  0.74. In the year 1972, what is the difference between the Female students (as % of total students) of World and Female students (as % of total students) of Tunisia?
Your answer should be compact. 13.94. In the year 1972, what is the difference between the Female students (as % of total students) of Cabo Verde and Female students (as % of total students) of Netherlands?
Make the answer very short. 7.26. In the year 1972, what is the difference between the Female students (as % of total students) in Cabo Verde and Female students (as % of total students) in Tunisia?
Give a very brief answer. 20.45. In the year 1972, what is the difference between the Female students (as % of total students) in Netherlands and Female students (as % of total students) in Tunisia?
Your answer should be very brief. 13.19. In the year 1987, what is the difference between the Female students (as % of total students) in World and Female students (as % of total students) in Cabo Verde?
Your answer should be compact. 8.74. In the year 1987, what is the difference between the Female students (as % of total students) in World and Female students (as % of total students) in Netherlands?
Provide a short and direct response. 2.33. In the year 1987, what is the difference between the Female students (as % of total students) in World and Female students (as % of total students) in Tunisia?
Offer a terse response. 6.17. In the year 1987, what is the difference between the Female students (as % of total students) of Cabo Verde and Female students (as % of total students) of Netherlands?
Give a very brief answer. -6.41. In the year 1987, what is the difference between the Female students (as % of total students) of Cabo Verde and Female students (as % of total students) of Tunisia?
Your answer should be very brief. -2.57. In the year 1987, what is the difference between the Female students (as % of total students) of Netherlands and Female students (as % of total students) of Tunisia?
Keep it short and to the point. 3.85. In the year 1988, what is the difference between the Female students (as % of total students) of World and Female students (as % of total students) of Cabo Verde?
Your answer should be compact. 7.01. In the year 1988, what is the difference between the Female students (as % of total students) in World and Female students (as % of total students) in Netherlands?
Make the answer very short. 3.04. In the year 1988, what is the difference between the Female students (as % of total students) in World and Female students (as % of total students) in Tunisia?
Your response must be concise. 6.12. In the year 1988, what is the difference between the Female students (as % of total students) of Cabo Verde and Female students (as % of total students) of Netherlands?
Your answer should be very brief. -3.97. In the year 1988, what is the difference between the Female students (as % of total students) in Cabo Verde and Female students (as % of total students) in Tunisia?
Provide a short and direct response. -0.89. In the year 1988, what is the difference between the Female students (as % of total students) in Netherlands and Female students (as % of total students) in Tunisia?
Make the answer very short. 3.08. In the year 1989, what is the difference between the Female students (as % of total students) in World and Female students (as % of total students) in Cabo Verde?
Your response must be concise. 4.44. In the year 1989, what is the difference between the Female students (as % of total students) in World and Female students (as % of total students) in Netherlands?
Make the answer very short. 2.86. In the year 1989, what is the difference between the Female students (as % of total students) of World and Female students (as % of total students) of Tunisia?
Provide a succinct answer. 5.97. In the year 1989, what is the difference between the Female students (as % of total students) of Cabo Verde and Female students (as % of total students) of Netherlands?
Provide a short and direct response. -1.58. In the year 1989, what is the difference between the Female students (as % of total students) of Cabo Verde and Female students (as % of total students) of Tunisia?
Your answer should be very brief. 1.53. In the year 1989, what is the difference between the Female students (as % of total students) in Netherlands and Female students (as % of total students) in Tunisia?
Give a very brief answer. 3.11. In the year 1990, what is the difference between the Female students (as % of total students) of World and Female students (as % of total students) of Cabo Verde?
Make the answer very short. 4.55. In the year 1990, what is the difference between the Female students (as % of total students) of World and Female students (as % of total students) of Netherlands?
Make the answer very short. 2.33. In the year 1990, what is the difference between the Female students (as % of total students) of World and Female students (as % of total students) of Tunisia?
Give a very brief answer. 5.27. In the year 1990, what is the difference between the Female students (as % of total students) in Cabo Verde and Female students (as % of total students) in Netherlands?
Your answer should be compact. -2.21. In the year 1990, what is the difference between the Female students (as % of total students) of Cabo Verde and Female students (as % of total students) of Tunisia?
Provide a succinct answer. 0.72. In the year 1990, what is the difference between the Female students (as % of total students) in Netherlands and Female students (as % of total students) in Tunisia?
Your answer should be very brief. 2.93. In the year 1994, what is the difference between the Female students (as % of total students) in World and Female students (as % of total students) in Cabo Verde?
Keep it short and to the point. 5.64. In the year 1994, what is the difference between the Female students (as % of total students) in World and Female students (as % of total students) in Netherlands?
Provide a succinct answer. 3.16. In the year 1994, what is the difference between the Female students (as % of total students) of World and Female students (as % of total students) of Tunisia?
Ensure brevity in your answer.  -3.8. In the year 1994, what is the difference between the Female students (as % of total students) of Cabo Verde and Female students (as % of total students) of Netherlands?
Keep it short and to the point. -2.48. In the year 1994, what is the difference between the Female students (as % of total students) in Cabo Verde and Female students (as % of total students) in Tunisia?
Your answer should be very brief. -9.44. In the year 1994, what is the difference between the Female students (as % of total students) in Netherlands and Female students (as % of total students) in Tunisia?
Make the answer very short. -6.96. In the year 2001, what is the difference between the Female students (as % of total students) of World and Female students (as % of total students) of Cabo Verde?
Offer a terse response. 6.22. In the year 2001, what is the difference between the Female students (as % of total students) in World and Female students (as % of total students) in Netherlands?
Give a very brief answer. -1.08. In the year 2001, what is the difference between the Female students (as % of total students) in World and Female students (as % of total students) in Tunisia?
Give a very brief answer. -4.55. In the year 2001, what is the difference between the Female students (as % of total students) in Cabo Verde and Female students (as % of total students) in Netherlands?
Ensure brevity in your answer.  -7.3. In the year 2001, what is the difference between the Female students (as % of total students) of Cabo Verde and Female students (as % of total students) of Tunisia?
Your answer should be very brief. -10.78. In the year 2001, what is the difference between the Female students (as % of total students) of Netherlands and Female students (as % of total students) of Tunisia?
Ensure brevity in your answer.  -3.48. In the year 2002, what is the difference between the Female students (as % of total students) in World and Female students (as % of total students) in Cabo Verde?
Your answer should be compact. 4.21. In the year 2002, what is the difference between the Female students (as % of total students) of World and Female students (as % of total students) of Netherlands?
Keep it short and to the point. -1.76. In the year 2002, what is the difference between the Female students (as % of total students) in World and Female students (as % of total students) in Tunisia?
Provide a short and direct response. 6.14. In the year 2002, what is the difference between the Female students (as % of total students) of Cabo Verde and Female students (as % of total students) of Netherlands?
Ensure brevity in your answer.  -5.97. In the year 2002, what is the difference between the Female students (as % of total students) in Cabo Verde and Female students (as % of total students) in Tunisia?
Offer a terse response. 1.93. In the year 2002, what is the difference between the Female students (as % of total students) in Netherlands and Female students (as % of total students) in Tunisia?
Ensure brevity in your answer.  7.9. What is the ratio of the Female students (as % of total students) in World in 1972 to that in 1987?
Your response must be concise. 0.94. What is the ratio of the Female students (as % of total students) in Cabo Verde in 1972 to that in 1987?
Keep it short and to the point. 1.34. What is the ratio of the Female students (as % of total students) in Netherlands in 1972 to that in 1987?
Offer a very short reply. 0.97. What is the ratio of the Female students (as % of total students) of Tunisia in 1972 to that in 1987?
Provide a succinct answer. 0.73. What is the ratio of the Female students (as % of total students) of World in 1972 to that in 1988?
Make the answer very short. 0.94. What is the ratio of the Female students (as % of total students) of Cabo Verde in 1972 to that in 1988?
Offer a very short reply. 1.29. What is the ratio of the Female students (as % of total students) in Netherlands in 1972 to that in 1988?
Your answer should be very brief. 0.99. What is the ratio of the Female students (as % of total students) in Tunisia in 1972 to that in 1988?
Offer a terse response. 0.73. What is the ratio of the Female students (as % of total students) in World in 1972 to that in 1989?
Provide a short and direct response. 0.94. What is the ratio of the Female students (as % of total students) in Cabo Verde in 1972 to that in 1989?
Provide a short and direct response. 1.21. What is the ratio of the Female students (as % of total students) in Tunisia in 1972 to that in 1989?
Provide a succinct answer. 0.73. What is the ratio of the Female students (as % of total students) of World in 1972 to that in 1990?
Provide a short and direct response. 0.96. What is the ratio of the Female students (as % of total students) of Cabo Verde in 1972 to that in 1990?
Provide a short and direct response. 1.24. What is the ratio of the Female students (as % of total students) of Netherlands in 1972 to that in 1990?
Your answer should be compact. 1. What is the ratio of the Female students (as % of total students) of Tunisia in 1972 to that in 1990?
Provide a short and direct response. 0.73. What is the ratio of the Female students (as % of total students) in World in 1972 to that in 1994?
Give a very brief answer. 0.95. What is the ratio of the Female students (as % of total students) of Cabo Verde in 1972 to that in 1994?
Your response must be concise. 1.26. What is the ratio of the Female students (as % of total students) of Netherlands in 1972 to that in 1994?
Your response must be concise. 1.01. What is the ratio of the Female students (as % of total students) in Tunisia in 1972 to that in 1994?
Your answer should be very brief. 0.59. What is the ratio of the Female students (as % of total students) in World in 1972 to that in 2001?
Your answer should be very brief. 0.95. What is the ratio of the Female students (as % of total students) in Cabo Verde in 1972 to that in 2001?
Provide a short and direct response. 1.28. What is the ratio of the Female students (as % of total students) in Netherlands in 1972 to that in 2001?
Give a very brief answer. 0.91. What is the ratio of the Female students (as % of total students) of Tunisia in 1972 to that in 2001?
Your answer should be compact. 0.58. What is the ratio of the Female students (as % of total students) in World in 1972 to that in 2002?
Provide a short and direct response. 0.96. What is the ratio of the Female students (as % of total students) in Cabo Verde in 1972 to that in 2002?
Ensure brevity in your answer.  1.23. What is the ratio of the Female students (as % of total students) in Netherlands in 1972 to that in 2002?
Your answer should be compact. 0.91. What is the ratio of the Female students (as % of total students) in Tunisia in 1972 to that in 2002?
Offer a very short reply. 0.75. What is the ratio of the Female students (as % of total students) in World in 1987 to that in 1988?
Offer a terse response. 1. What is the ratio of the Female students (as % of total students) of Cabo Verde in 1987 to that in 1988?
Make the answer very short. 0.96. What is the ratio of the Female students (as % of total students) of Netherlands in 1987 to that in 1988?
Provide a short and direct response. 1.02. What is the ratio of the Female students (as % of total students) of World in 1987 to that in 1989?
Provide a succinct answer. 1. What is the ratio of the Female students (as % of total students) of Cabo Verde in 1987 to that in 1989?
Your answer should be very brief. 0.9. What is the ratio of the Female students (as % of total students) of Netherlands in 1987 to that in 1989?
Offer a very short reply. 1.01. What is the ratio of the Female students (as % of total students) in Tunisia in 1987 to that in 1989?
Keep it short and to the point. 1. What is the ratio of the Female students (as % of total students) in World in 1987 to that in 1990?
Make the answer very short. 1.02. What is the ratio of the Female students (as % of total students) in Cabo Verde in 1987 to that in 1990?
Your answer should be very brief. 0.92. What is the ratio of the Female students (as % of total students) of Netherlands in 1987 to that in 1990?
Offer a very short reply. 1.02. What is the ratio of the Female students (as % of total students) in World in 1987 to that in 1994?
Ensure brevity in your answer.  1.01. What is the ratio of the Female students (as % of total students) in Cabo Verde in 1987 to that in 1994?
Provide a succinct answer. 0.94. What is the ratio of the Female students (as % of total students) of Netherlands in 1987 to that in 1994?
Ensure brevity in your answer.  1.03. What is the ratio of the Female students (as % of total students) of Tunisia in 1987 to that in 1994?
Your response must be concise. 0.81. What is the ratio of the Female students (as % of total students) in World in 1987 to that in 2001?
Offer a very short reply. 1.01. What is the ratio of the Female students (as % of total students) of Cabo Verde in 1987 to that in 2001?
Give a very brief answer. 0.95. What is the ratio of the Female students (as % of total students) in Netherlands in 1987 to that in 2001?
Offer a very short reply. 0.94. What is the ratio of the Female students (as % of total students) in Tunisia in 1987 to that in 2001?
Your response must be concise. 0.79. What is the ratio of the Female students (as % of total students) of Cabo Verde in 1987 to that in 2002?
Offer a very short reply. 0.91. What is the ratio of the Female students (as % of total students) of Netherlands in 1987 to that in 2002?
Make the answer very short. 0.93. What is the ratio of the Female students (as % of total students) of Tunisia in 1987 to that in 2002?
Your answer should be compact. 1.03. What is the ratio of the Female students (as % of total students) in Cabo Verde in 1988 to that in 1989?
Your response must be concise. 0.94. What is the ratio of the Female students (as % of total students) in Netherlands in 1988 to that in 1989?
Keep it short and to the point. 1. What is the ratio of the Female students (as % of total students) of Tunisia in 1988 to that in 1989?
Provide a succinct answer. 1. What is the ratio of the Female students (as % of total students) in World in 1988 to that in 1990?
Provide a succinct answer. 1.02. What is the ratio of the Female students (as % of total students) in Cabo Verde in 1988 to that in 1990?
Your answer should be very brief. 0.96. What is the ratio of the Female students (as % of total students) of Tunisia in 1988 to that in 1990?
Offer a very short reply. 1. What is the ratio of the Female students (as % of total students) in World in 1988 to that in 1994?
Your answer should be very brief. 1.01. What is the ratio of the Female students (as % of total students) in Cabo Verde in 1988 to that in 1994?
Offer a very short reply. 0.98. What is the ratio of the Female students (as % of total students) in Netherlands in 1988 to that in 1994?
Give a very brief answer. 1.02. What is the ratio of the Female students (as % of total students) in Tunisia in 1988 to that in 1994?
Give a very brief answer. 0.81. What is the ratio of the Female students (as % of total students) in World in 1988 to that in 2001?
Your answer should be compact. 1.01. What is the ratio of the Female students (as % of total students) in Cabo Verde in 1988 to that in 2001?
Your response must be concise. 0.99. What is the ratio of the Female students (as % of total students) in Netherlands in 1988 to that in 2001?
Offer a very short reply. 0.92. What is the ratio of the Female students (as % of total students) in Tunisia in 1988 to that in 2001?
Offer a very short reply. 0.79. What is the ratio of the Female students (as % of total students) in World in 1988 to that in 2002?
Provide a short and direct response. 1.02. What is the ratio of the Female students (as % of total students) of Cabo Verde in 1988 to that in 2002?
Offer a terse response. 0.95. What is the ratio of the Female students (as % of total students) of Netherlands in 1988 to that in 2002?
Your answer should be compact. 0.92. What is the ratio of the Female students (as % of total students) in Tunisia in 1988 to that in 2002?
Provide a succinct answer. 1.03. What is the ratio of the Female students (as % of total students) of World in 1989 to that in 1990?
Make the answer very short. 1.02. What is the ratio of the Female students (as % of total students) of Cabo Verde in 1989 to that in 1990?
Your answer should be compact. 1.02. What is the ratio of the Female students (as % of total students) of Netherlands in 1989 to that in 1990?
Offer a very short reply. 1.01. What is the ratio of the Female students (as % of total students) of Tunisia in 1989 to that in 1990?
Your answer should be very brief. 1. What is the ratio of the Female students (as % of total students) in World in 1989 to that in 1994?
Give a very brief answer. 1.01. What is the ratio of the Female students (as % of total students) in Cabo Verde in 1989 to that in 1994?
Provide a short and direct response. 1.04. What is the ratio of the Female students (as % of total students) in Netherlands in 1989 to that in 1994?
Your answer should be very brief. 1.02. What is the ratio of the Female students (as % of total students) of Tunisia in 1989 to that in 1994?
Make the answer very short. 0.81. What is the ratio of the Female students (as % of total students) of World in 1989 to that in 2001?
Offer a very short reply. 1.01. What is the ratio of the Female students (as % of total students) of Cabo Verde in 1989 to that in 2001?
Your answer should be compact. 1.06. What is the ratio of the Female students (as % of total students) of Netherlands in 1989 to that in 2001?
Your response must be concise. 0.92. What is the ratio of the Female students (as % of total students) of Tunisia in 1989 to that in 2001?
Your answer should be compact. 0.8. What is the ratio of the Female students (as % of total students) of Cabo Verde in 1989 to that in 2002?
Make the answer very short. 1.02. What is the ratio of the Female students (as % of total students) of Netherlands in 1989 to that in 2002?
Provide a succinct answer. 0.92. What is the ratio of the Female students (as % of total students) of Tunisia in 1989 to that in 2002?
Your answer should be compact. 1.03. What is the ratio of the Female students (as % of total students) of Cabo Verde in 1990 to that in 1994?
Offer a terse response. 1.02. What is the ratio of the Female students (as % of total students) of Netherlands in 1990 to that in 1994?
Keep it short and to the point. 1.01. What is the ratio of the Female students (as % of total students) of Tunisia in 1990 to that in 1994?
Ensure brevity in your answer.  0.81. What is the ratio of the Female students (as % of total students) of World in 1990 to that in 2001?
Provide a short and direct response. 0.99. What is the ratio of the Female students (as % of total students) of Cabo Verde in 1990 to that in 2001?
Provide a short and direct response. 1.03. What is the ratio of the Female students (as % of total students) of Netherlands in 1990 to that in 2001?
Your answer should be very brief. 0.92. What is the ratio of the Female students (as % of total students) in Tunisia in 1990 to that in 2001?
Offer a very short reply. 0.79. What is the ratio of the Female students (as % of total students) in Netherlands in 1990 to that in 2002?
Offer a very short reply. 0.91. What is the ratio of the Female students (as % of total students) of Tunisia in 1990 to that in 2002?
Offer a terse response. 1.02. What is the ratio of the Female students (as % of total students) in World in 1994 to that in 2001?
Your answer should be compact. 1. What is the ratio of the Female students (as % of total students) of Cabo Verde in 1994 to that in 2001?
Give a very brief answer. 1.01. What is the ratio of the Female students (as % of total students) of Netherlands in 1994 to that in 2001?
Your answer should be very brief. 0.91. What is the ratio of the Female students (as % of total students) in Tunisia in 1994 to that in 2001?
Offer a very short reply. 0.98. What is the ratio of the Female students (as % of total students) in World in 1994 to that in 2002?
Make the answer very short. 1.01. What is the ratio of the Female students (as % of total students) of Cabo Verde in 1994 to that in 2002?
Offer a terse response. 0.97. What is the ratio of the Female students (as % of total students) in Netherlands in 1994 to that in 2002?
Ensure brevity in your answer.  0.9. What is the ratio of the Female students (as % of total students) in Tunisia in 1994 to that in 2002?
Ensure brevity in your answer.  1.27. What is the ratio of the Female students (as % of total students) in World in 2001 to that in 2002?
Ensure brevity in your answer.  1.01. What is the ratio of the Female students (as % of total students) of Cabo Verde in 2001 to that in 2002?
Your answer should be very brief. 0.96. What is the ratio of the Female students (as % of total students) in Tunisia in 2001 to that in 2002?
Give a very brief answer. 1.29. What is the difference between the highest and the second highest Female students (as % of total students) in World?
Your answer should be very brief. 0.06. What is the difference between the highest and the second highest Female students (as % of total students) in Cabo Verde?
Your answer should be compact. 8.39. What is the difference between the highest and the second highest Female students (as % of total students) of Netherlands?
Ensure brevity in your answer.  0.18. What is the difference between the highest and the second highest Female students (as % of total students) in Tunisia?
Offer a very short reply. 0.85. What is the difference between the highest and the lowest Female students (as % of total students) of World?
Your response must be concise. 2.66. What is the difference between the highest and the lowest Female students (as % of total students) in Cabo Verde?
Offer a very short reply. 12.6. What is the difference between the highest and the lowest Female students (as % of total students) of Netherlands?
Offer a terse response. 4.5. What is the difference between the highest and the lowest Female students (as % of total students) of Tunisia?
Make the answer very short. 20.64. 